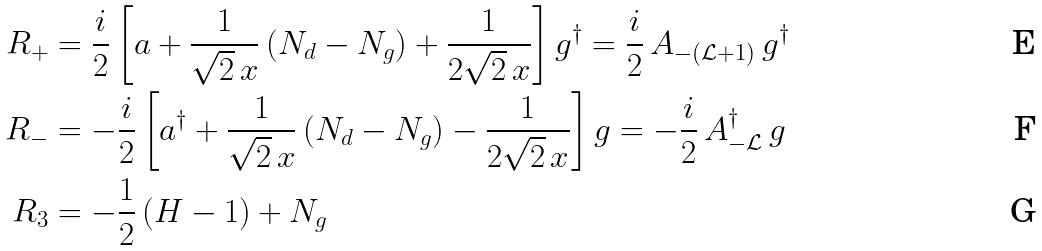<formula> <loc_0><loc_0><loc_500><loc_500>R _ { + } & = \frac { i } { 2 } \left [ a + \frac { 1 } { \sqrt { 2 } \, x } \left ( N _ { d } - N _ { g } \right ) + \frac { 1 } { 2 \sqrt { 2 } \, x } \right ] g ^ { \dag } = \frac { i } { 2 } \, A _ { - ( \mathcal { L } + 1 ) } \, g ^ { \dag } \\ R _ { - } & = - \frac { i } { 2 } \left [ a ^ { \dag } + \frac { 1 } { \sqrt { 2 } \, x } \left ( N _ { d } - N _ { g } \right ) - \frac { 1 } { 2 \sqrt { 2 } \, x } \right ] g = - \frac { i } { 2 } \, A _ { - \mathcal { L } } ^ { \dag } \, g \\ R _ { 3 } & = - \frac { 1 } { 2 } \left ( H - 1 \right ) + N _ { g }</formula> 